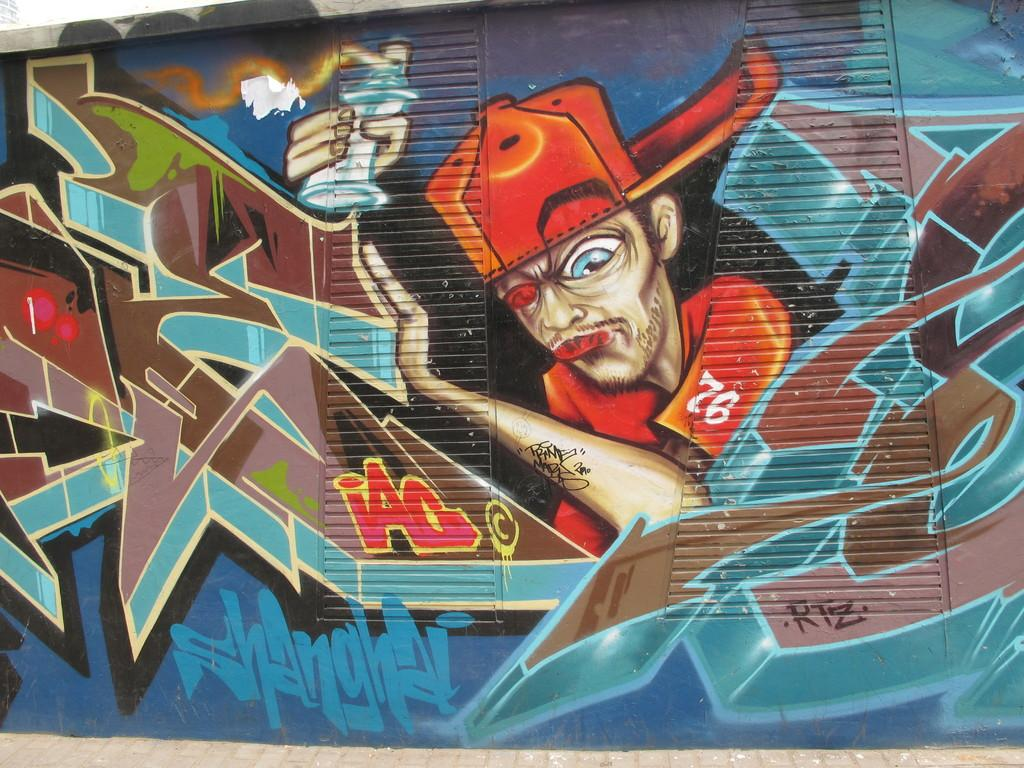What can be seen in the image? There is a wall in the image. What is on the wall? There is graffiti on the wall. How many icicles are hanging from the wall in the image? There are no icicles present in the image; it only features a wall with graffiti. What does the sister of the person who created the graffiti think about the artwork? There is no information about the person who created the graffiti or their sister in the image, so we cannot answer this question. 